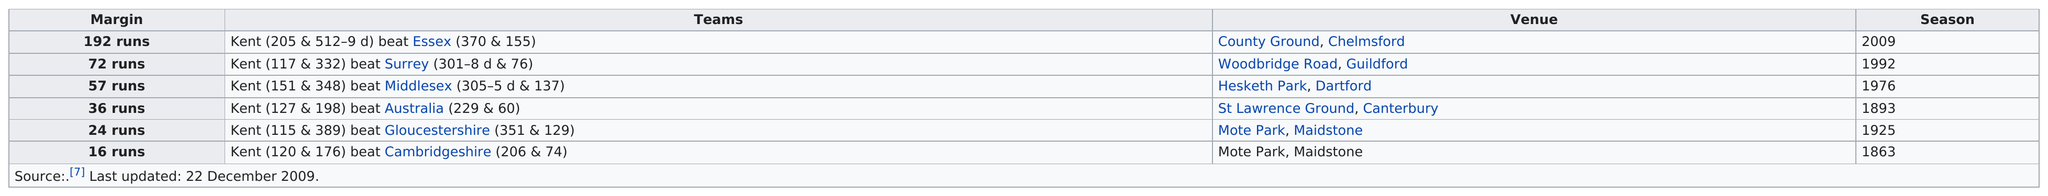Identify some key points in this picture. The Kent match that included the least amount of runs was against Gloucestershire. The difference in runs between Kent's matches against Surrey and Middlesex is 15. Kent scored more than 150 runs against Essex. 